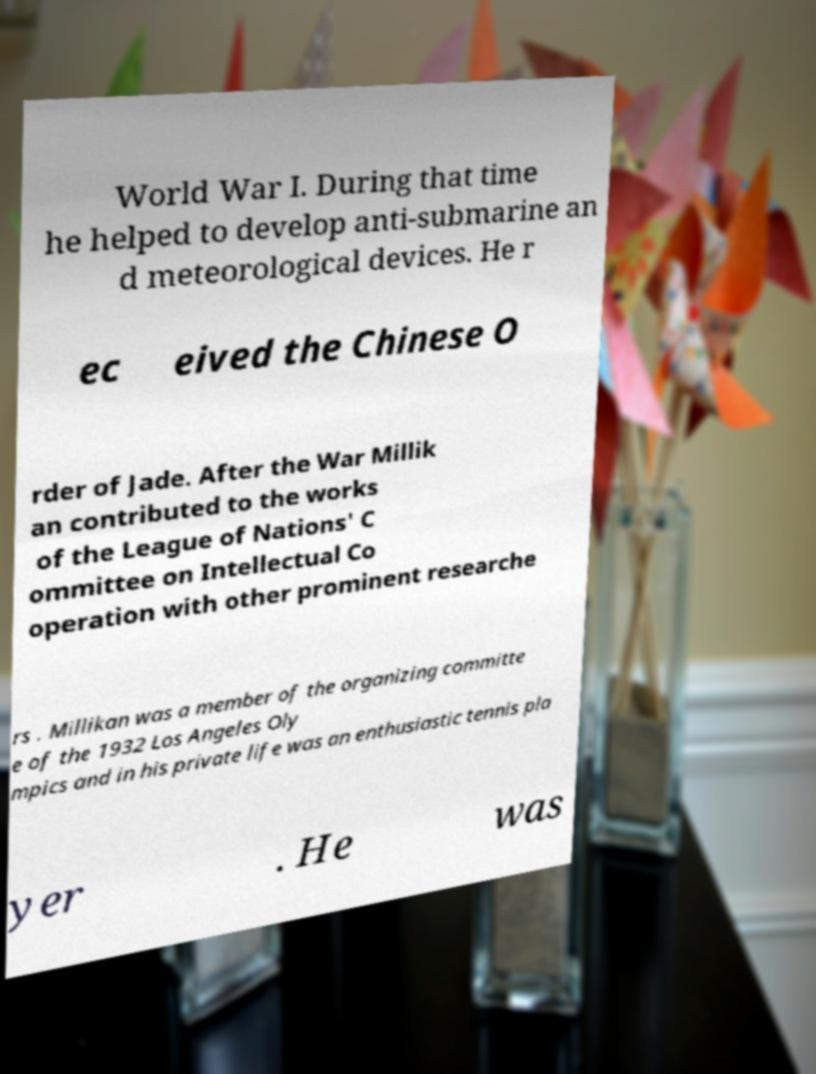Can you read and provide the text displayed in the image?This photo seems to have some interesting text. Can you extract and type it out for me? World War I. During that time he helped to develop anti-submarine an d meteorological devices. He r ec eived the Chinese O rder of Jade. After the War Millik an contributed to the works of the League of Nations' C ommittee on Intellectual Co operation with other prominent researche rs . Millikan was a member of the organizing committe e of the 1932 Los Angeles Oly mpics and in his private life was an enthusiastic tennis pla yer . He was 